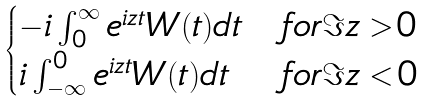Convert formula to latex. <formula><loc_0><loc_0><loc_500><loc_500>\begin{cases} - i \int _ { 0 } ^ { \infty } e ^ { i z t } W ( t ) d t & f o r \Im z > 0 \\ i \int _ { - \infty } ^ { 0 } e ^ { i z t } W ( t ) d t & f o r \Im z < 0 \end{cases}</formula> 